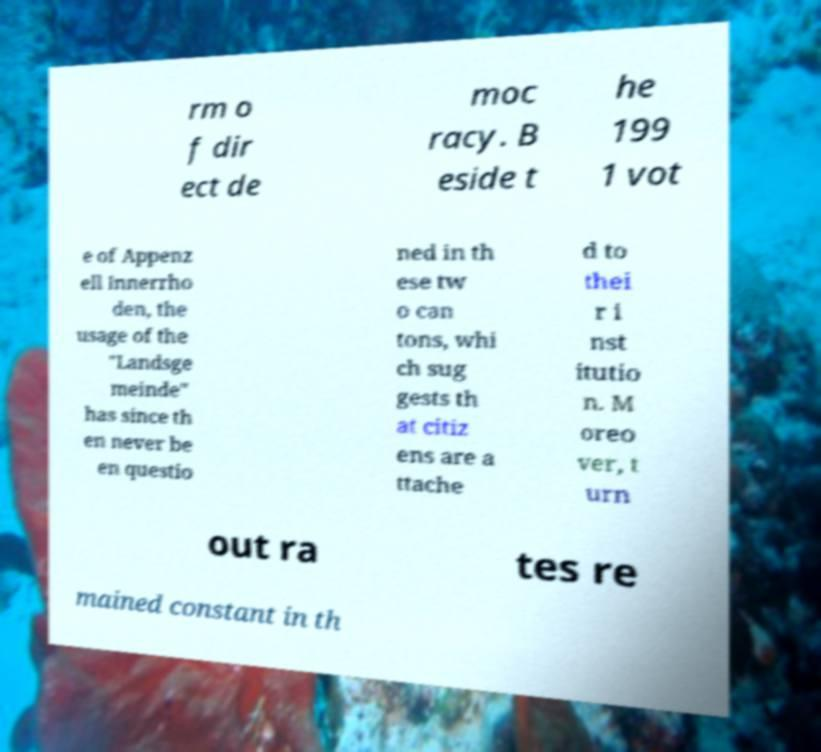Please read and relay the text visible in this image. What does it say? rm o f dir ect de moc racy. B eside t he 199 1 vot e of Appenz ell Innerrho den, the usage of the "Landsge meinde" has since th en never be en questio ned in th ese tw o can tons, whi ch sug gests th at citiz ens are a ttache d to thei r i nst itutio n. M oreo ver, t urn out ra tes re mained constant in th 